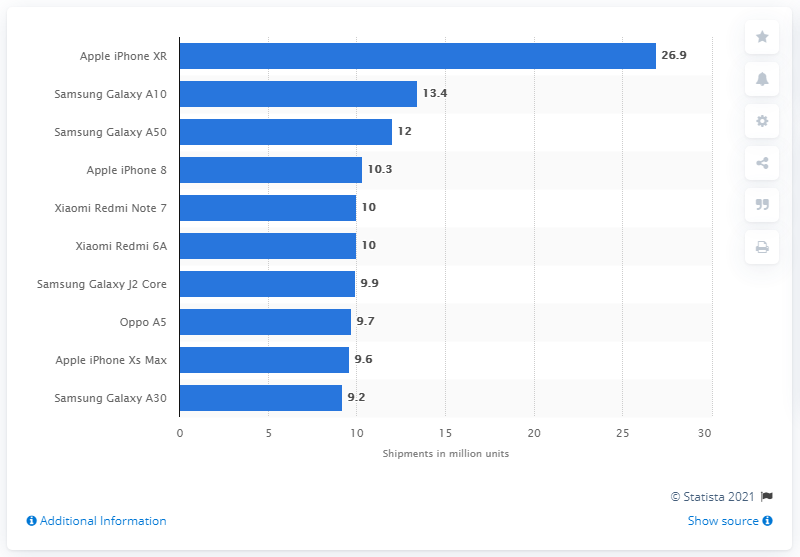Indicate a few pertinent items in this graphic. In the first half of 2019, 26.9 million iPhone XR units were shipped. 